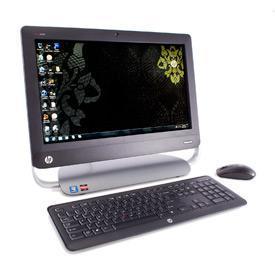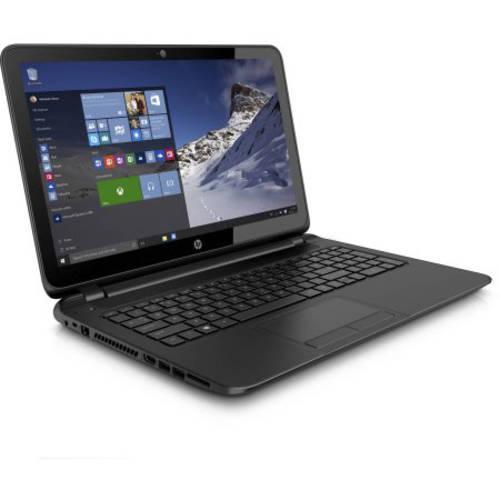The first image is the image on the left, the second image is the image on the right. Analyze the images presented: Is the assertion "the laptop on the right image has a black background" valid? Answer yes or no. No. The first image is the image on the left, the second image is the image on the right. For the images displayed, is the sentence "the laptop on the right image has a black background" factually correct? Answer yes or no. No. 